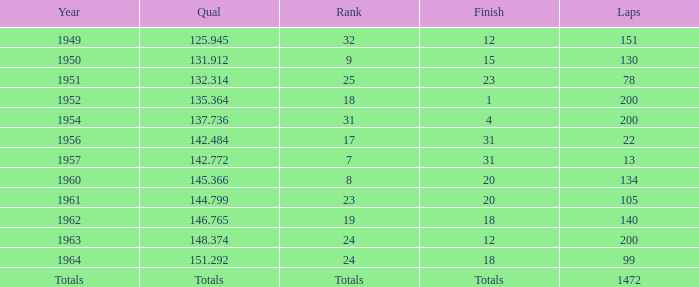Name the rank with finish of 12 and year of 1963 24.0. 